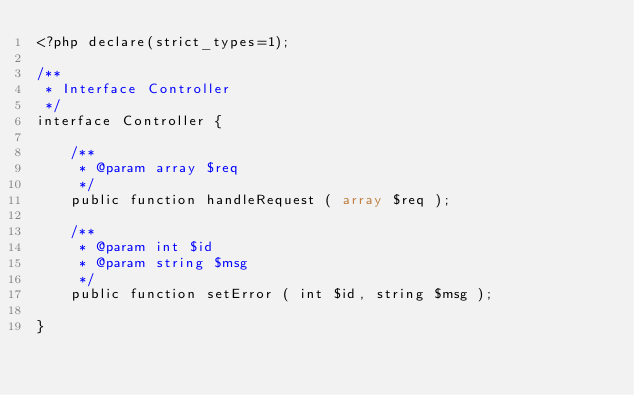<code> <loc_0><loc_0><loc_500><loc_500><_PHP_><?php declare(strict_types=1);

/**
 * Interface Controller
 */
interface Controller {

	/**
	 * @param array $req
	 */
	public function handleRequest ( array $req );

	/**
	 * @param int $id
	 * @param string $msg
	 */
	public function setError ( int $id, string $msg );

}</code> 